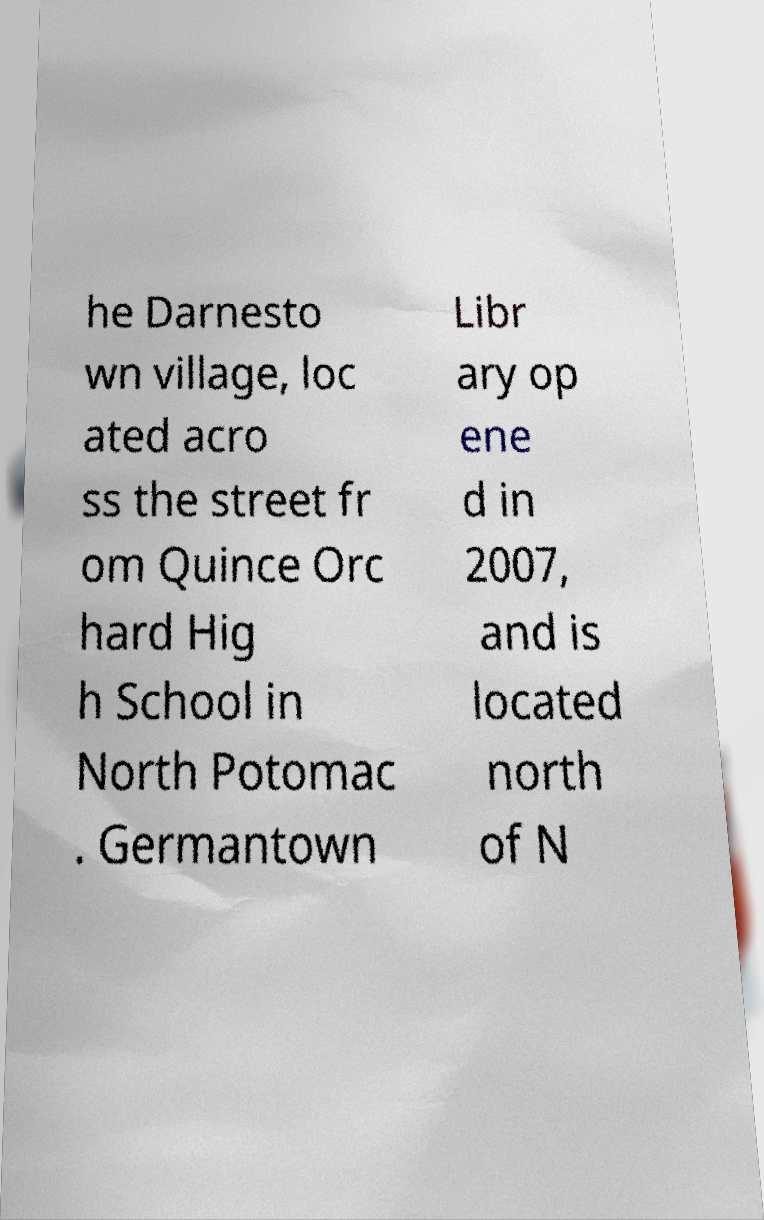Please read and relay the text visible in this image. What does it say? he Darnesto wn village, loc ated acro ss the street fr om Quince Orc hard Hig h School in North Potomac . Germantown Libr ary op ene d in 2007, and is located north of N 